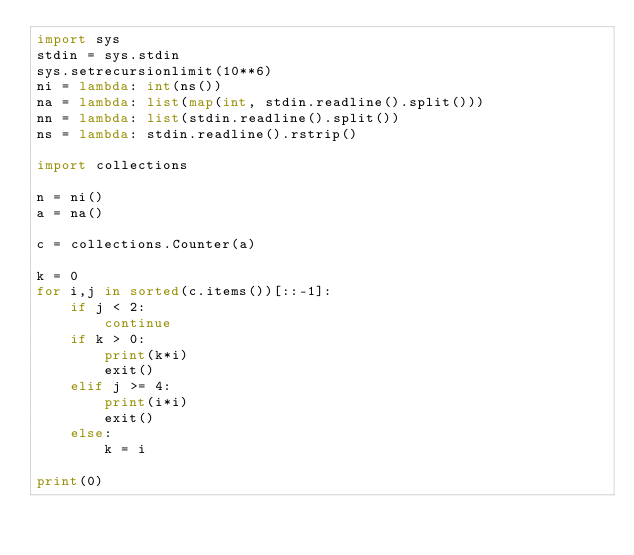Convert code to text. <code><loc_0><loc_0><loc_500><loc_500><_Python_>import sys
stdin = sys.stdin
sys.setrecursionlimit(10**6)
ni = lambda: int(ns())
na = lambda: list(map(int, stdin.readline().split()))
nn = lambda: list(stdin.readline().split())
ns = lambda: stdin.readline().rstrip()

import collections

n = ni()
a = na()

c = collections.Counter(a)

k = 0
for i,j in sorted(c.items())[::-1]:
    if j < 2:
        continue
    if k > 0:
        print(k*i)
        exit()
    elif j >= 4:
        print(i*i)
        exit()
    else:
        k = i

print(0)</code> 